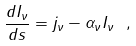<formula> <loc_0><loc_0><loc_500><loc_500>\frac { d I _ { \nu } } { d s } = j _ { \nu } - \alpha _ { \nu } I _ { \nu } \ ,</formula> 